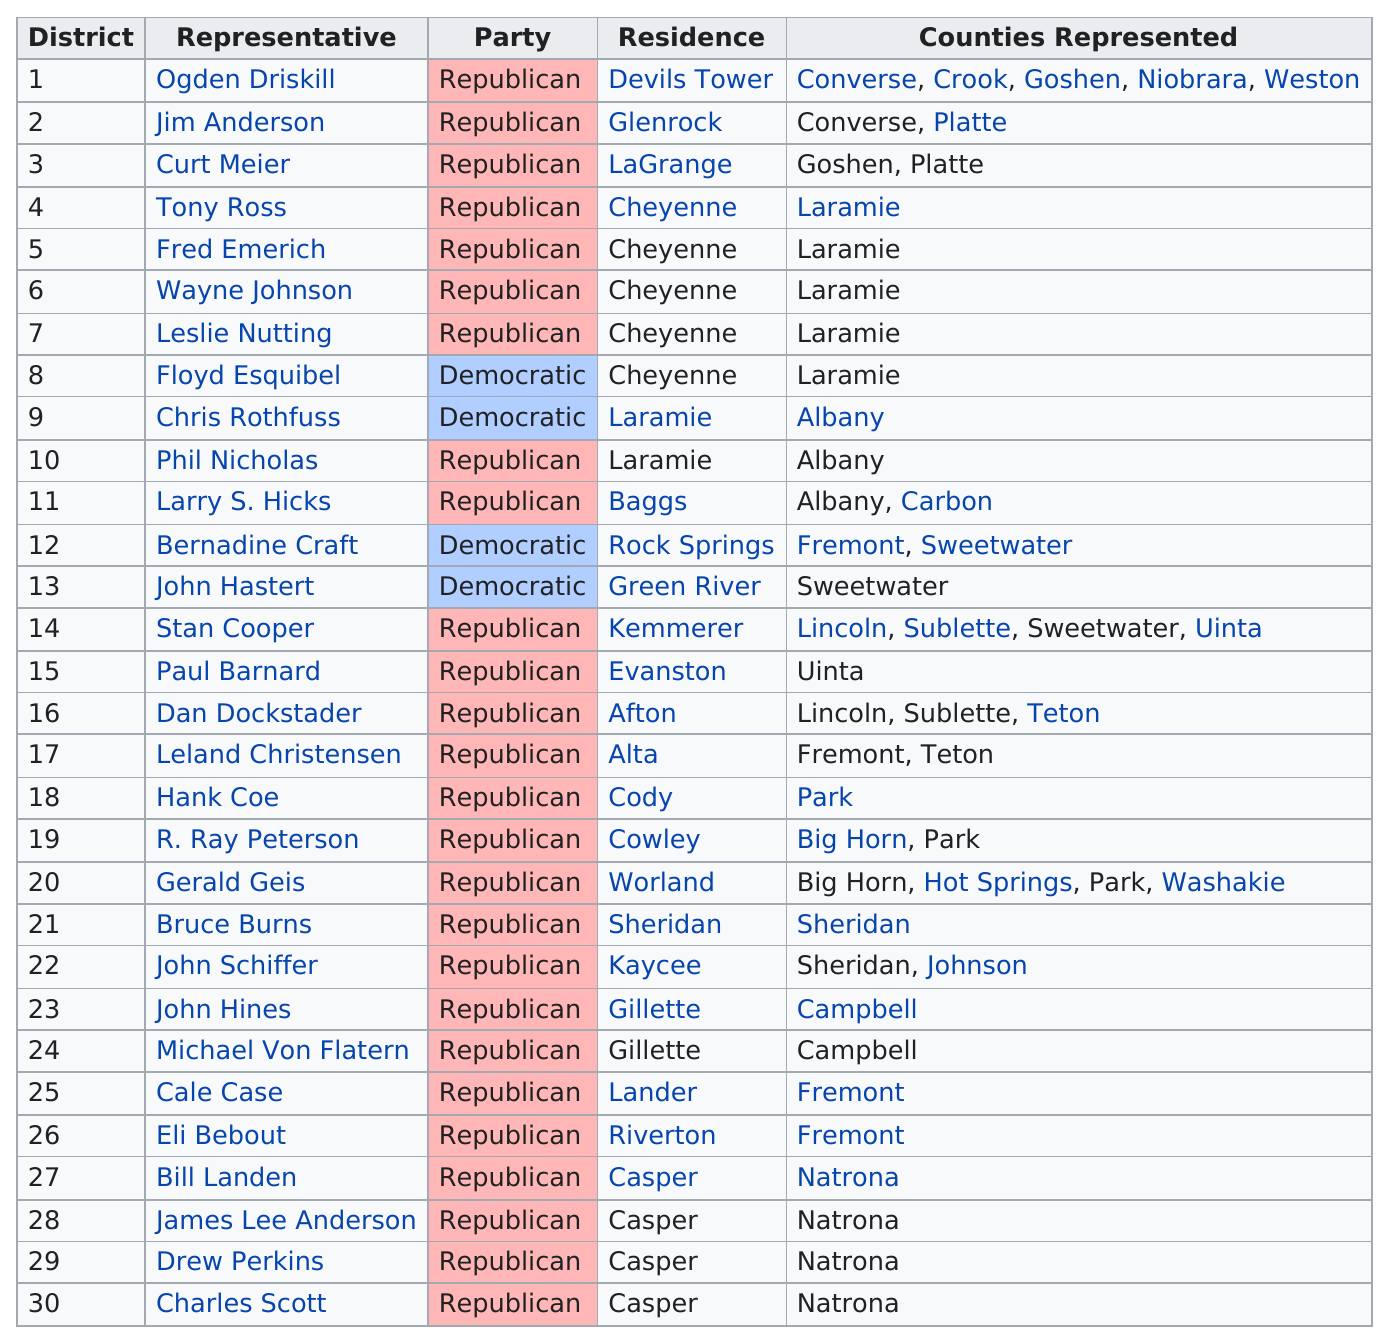Indicate a few pertinent items in this graphic. The State of Wyoming is represented by three Senators in the United States Congress, each serving a term of six years. Gerald Geis is representing a total of 4 counties. As of my knowledge cutoff date of September 2021, there are 26 Republican representatives. There are 4 democratic representatives. In the state of Wyoming, Senator Ogden Driskill represented the most counties among all representatives in the Senate. 